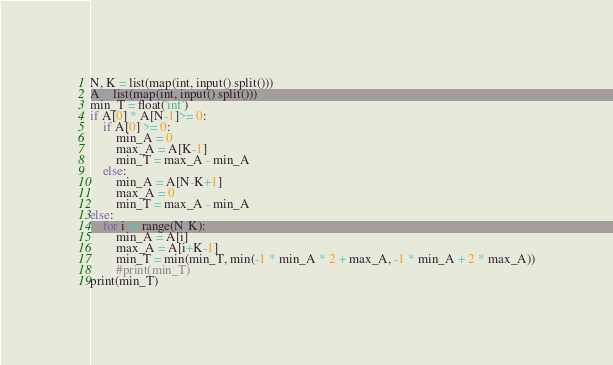<code> <loc_0><loc_0><loc_500><loc_500><_Python_>N, K = list(map(int, input().split()))
A = list(map(int, input().split()))
min_T = float('inf')
if A[0] * A[N-1]>= 0:
    if A[0] >= 0:
        min_A = 0
        max_A = A[K-1]
        min_T = max_A - min_A
    else:
        min_A = A[N-K+1]
        max_A = 0
        min_T = max_A - min_A
else:
    for i in range(N-K):
        min_A = A[i]
        max_A = A[i+K-1]
        min_T = min(min_T, min(-1 * min_A * 2 + max_A, -1 * min_A + 2 * max_A))
        #print(min_T)
print(min_T)
</code> 